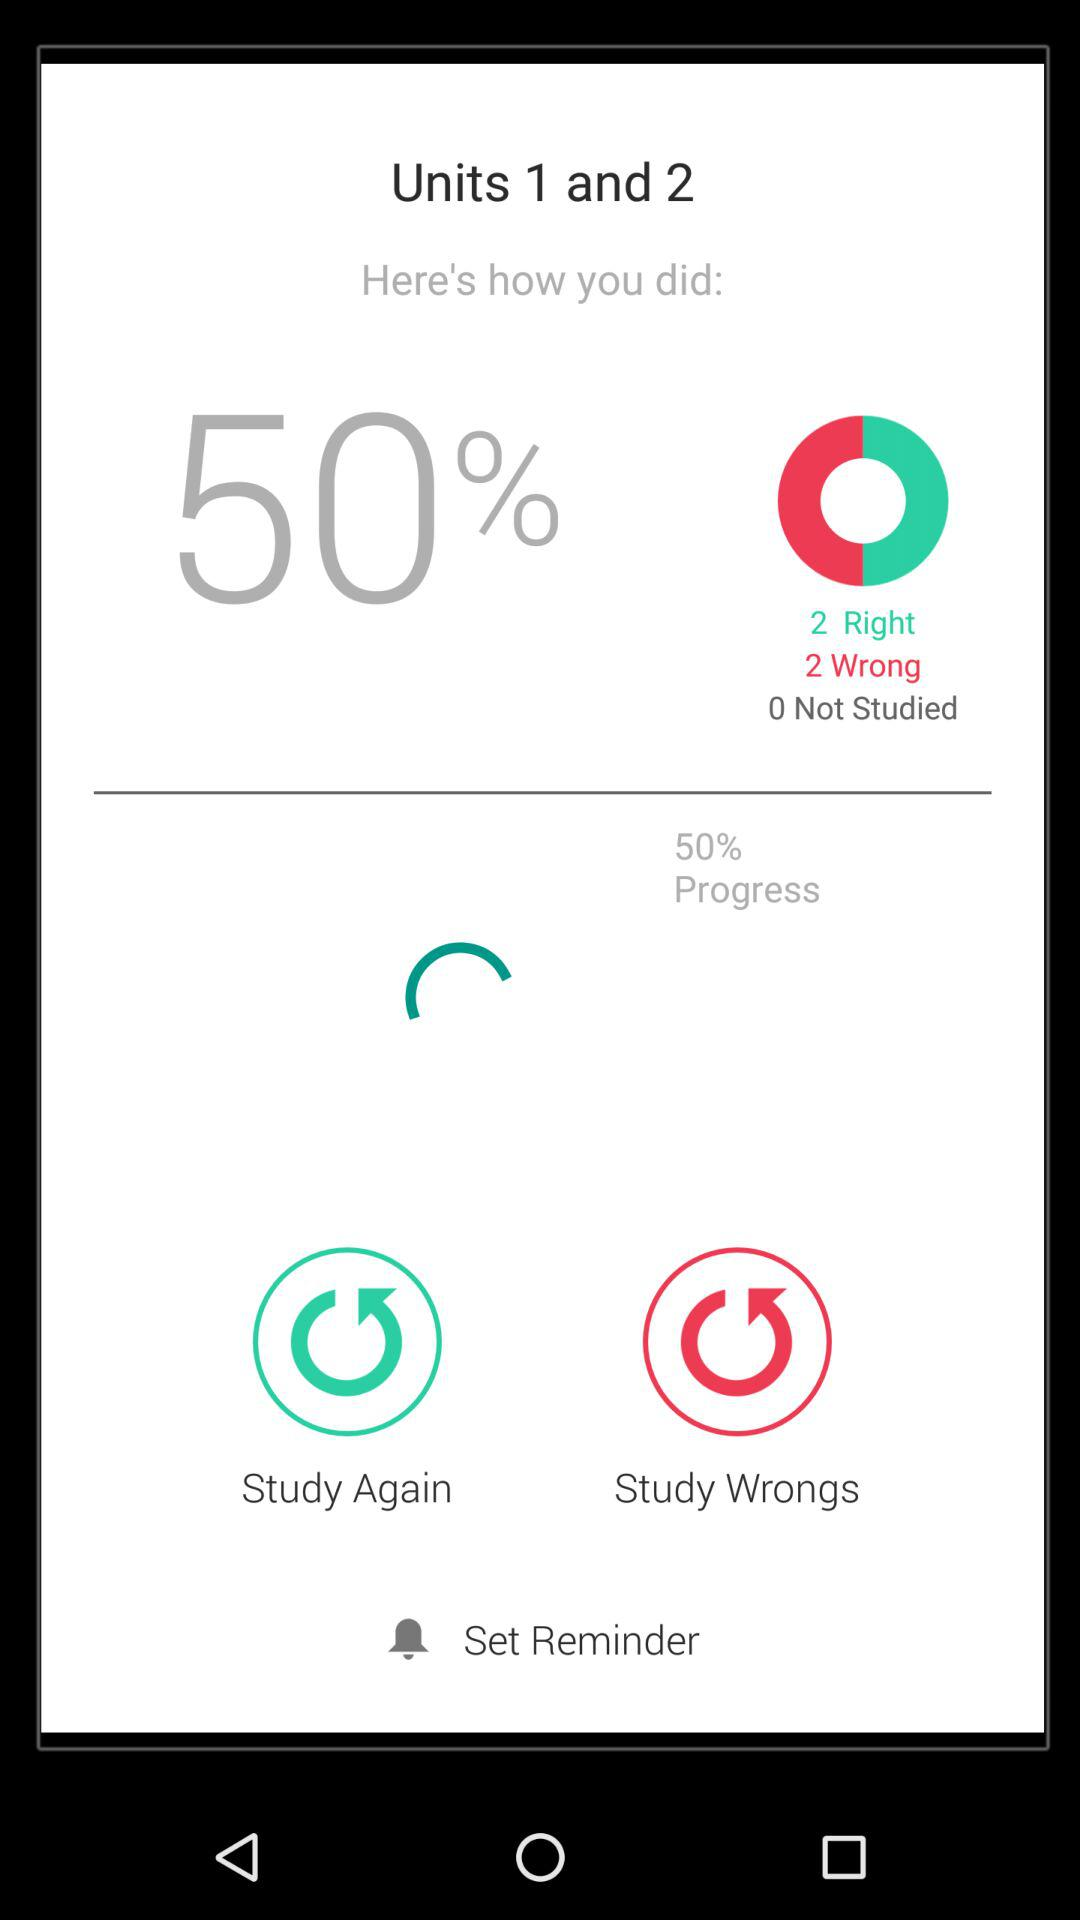What percentage of the units have been studied?
Answer the question using a single word or phrase. 50% 